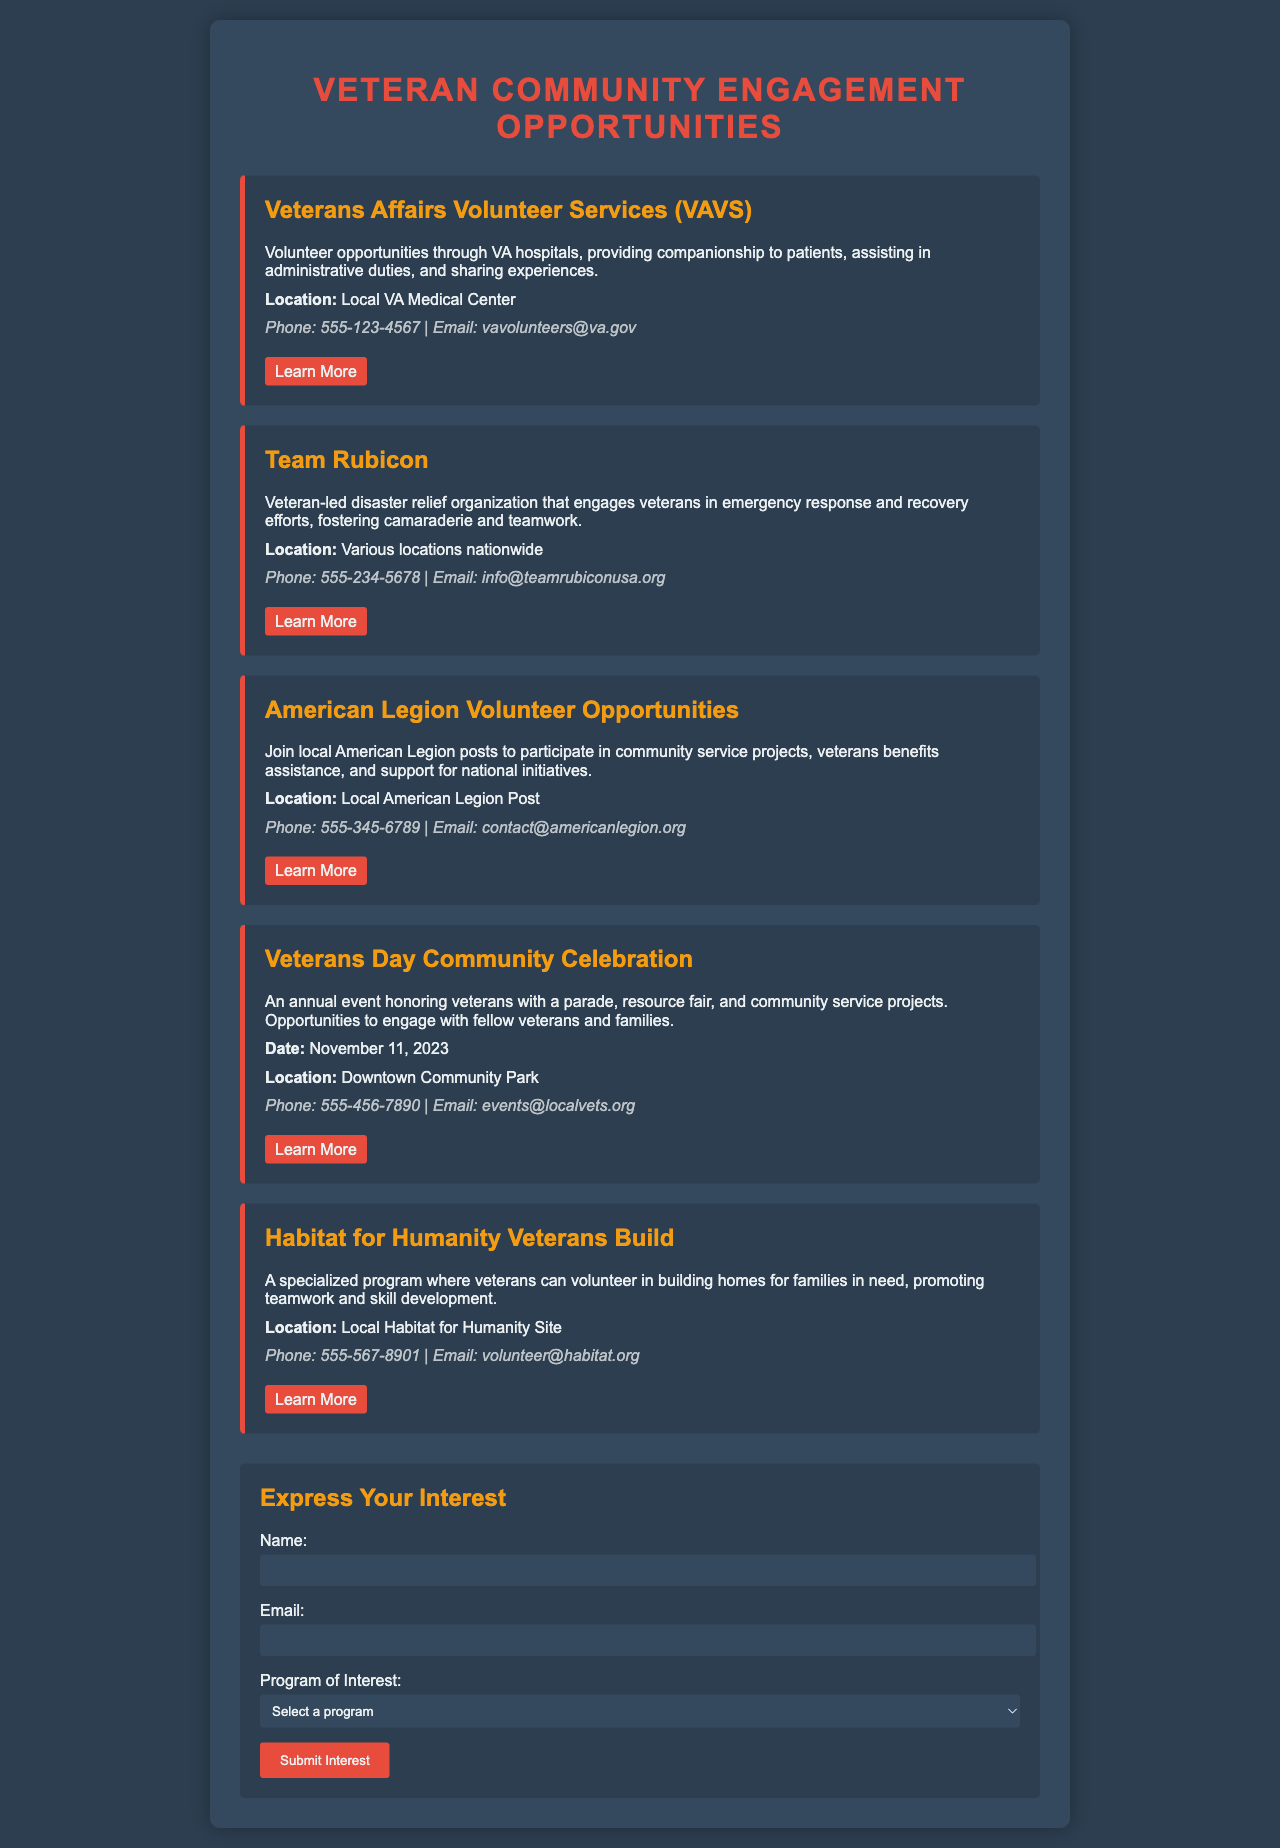What is the first volunteer opportunity listed? The first volunteer opportunity mentioned in the document is "Veterans Affairs Volunteer Services (VAVS)."
Answer: Veterans Affairs Volunteer Services (VAVS) What is the phone number for Team Rubicon? The phone number provided for Team Rubicon in the document is 555-234-5678.
Answer: 555-234-5678 When is the Veterans Day Community Celebration? The document states that the Veterans Day Community Celebration will take place on November 11, 2023.
Answer: November 11, 2023 What location is associated with the Habitat for Humanity Veterans Build? The document mentions the location for the Habitat for Humanity Veterans Build as "Local Habitat for Humanity Site."
Answer: Local Habitat for Humanity Site What organization provides volunteer programs specifically through VA hospitals? According to the document, the organization that provides volunteer programs through VA hospitals is "Veterans Affairs Volunteer Services (VAVS)."
Answer: Veterans Affairs Volunteer Services (VAVS) Which program allows veterans to engage in disaster relief efforts? The program that allows veterans to engage in disaster relief efforts is "Team Rubicon."
Answer: Team Rubicon What is the email contact for American Legion Volunteer Opportunities? The document specifies the email contact for American Legion Volunteer Opportunities as contact@americanlegion.org.
Answer: contact@americanlegion.org What type of event is the Veterans Day Community Celebration? The document describes the Veterans Day Community Celebration as an "annual event honoring veterans."
Answer: annual event honoring veterans Which program focuses on building homes for families in need? The program that focuses on building homes for families in need is "Habitat for Humanity Veterans Build."
Answer: Habitat for Humanity Veterans Build 